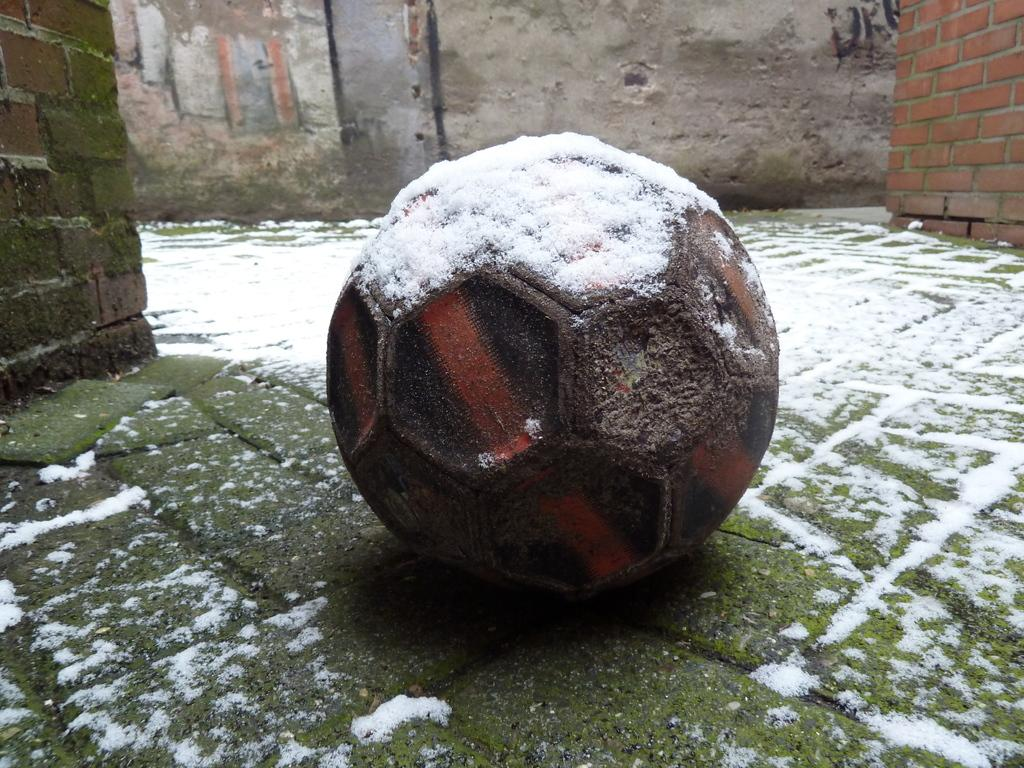What is the main subject in the center of the image? There is a ball in the center of the image. What is covering the ball? The ball has snow on it. What type of book is visible on the hydrant in the image? There is no hydrant or book present in the image; it only features a ball with snow on it. 